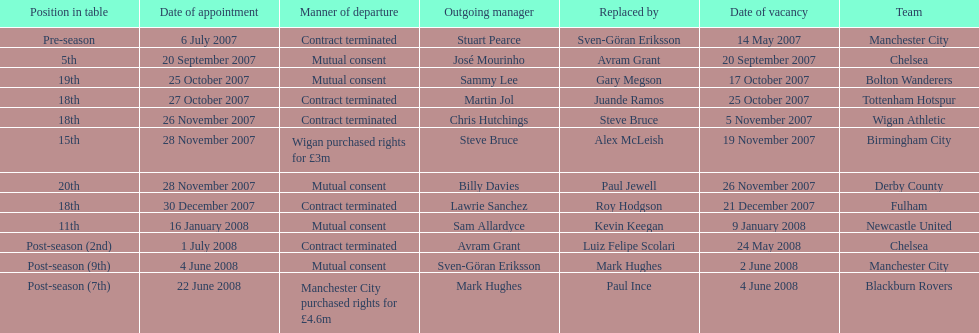Who was manager of manchester city after stuart pearce left in 2007? Sven-Göran Eriksson. 